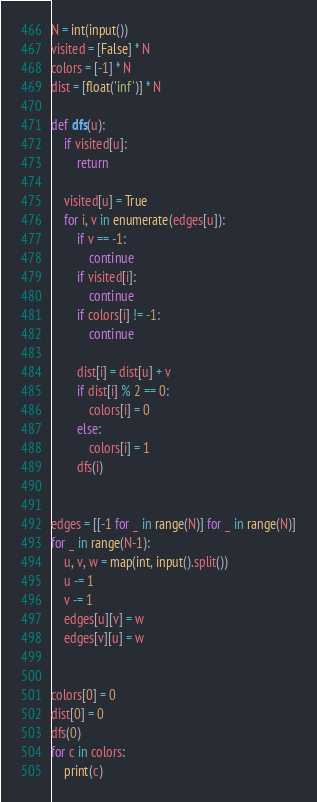<code> <loc_0><loc_0><loc_500><loc_500><_Python_>N = int(input())
visited = [False] * N
colors = [-1] * N
dist = [float('inf')] * N

def dfs(u):
    if visited[u]:
        return

    visited[u] = True
    for i, v in enumerate(edges[u]):
        if v == -1:
            continue
        if visited[i]:
            continue
        if colors[i] != -1:
            continue

        dist[i] = dist[u] + v
        if dist[i] % 2 == 0:
            colors[i] = 0
        else:
            colors[i] = 1
        dfs(i)


edges = [[-1 for _ in range(N)] for _ in range(N)]
for _ in range(N-1):
    u, v, w = map(int, input().split())
    u -= 1
    v -= 1
    edges[u][v] = w
    edges[v][u] = w


colors[0] = 0
dist[0] = 0
dfs(0)
for c in colors:
    print(c)</code> 